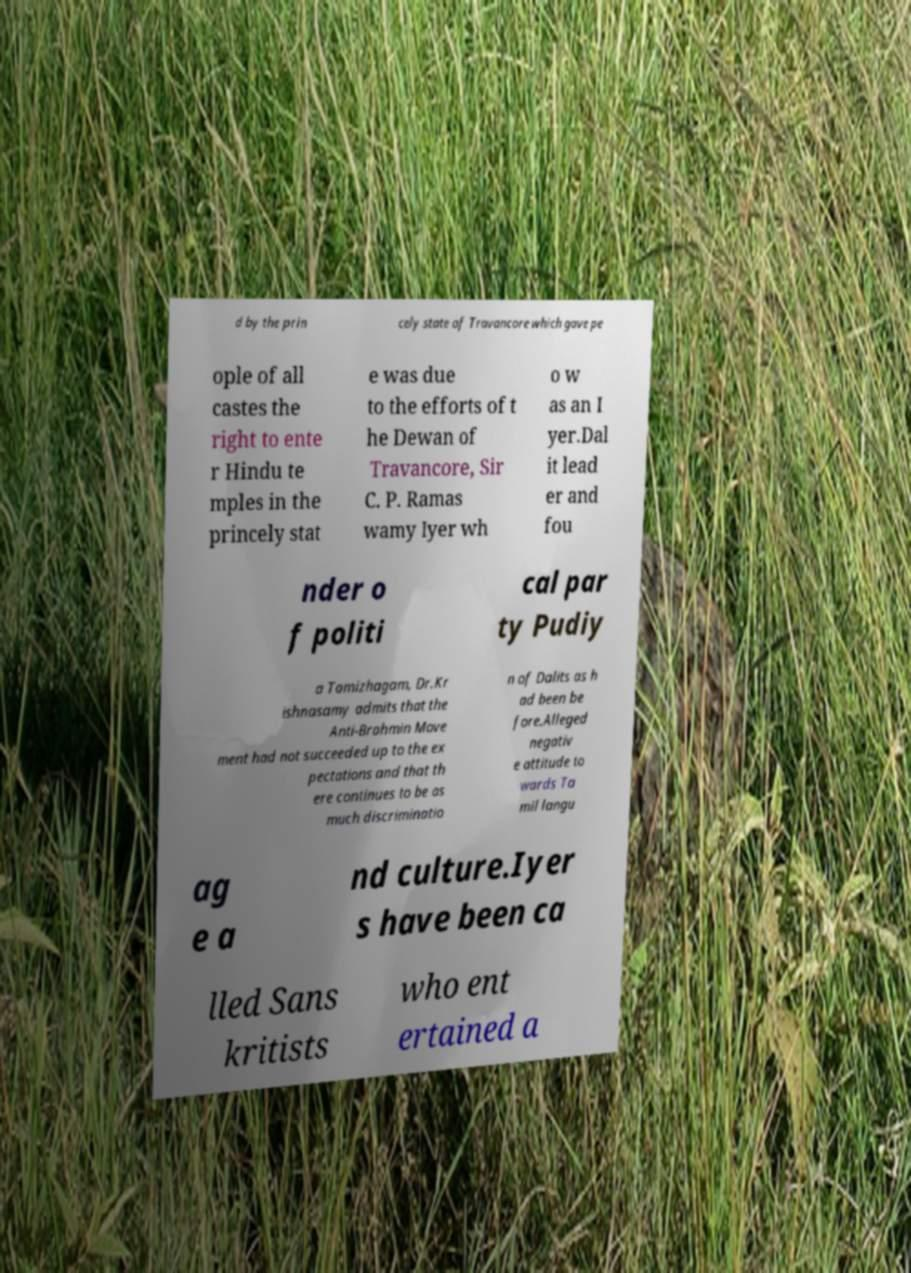Could you assist in decoding the text presented in this image and type it out clearly? d by the prin cely state of Travancore which gave pe ople of all castes the right to ente r Hindu te mples in the princely stat e was due to the efforts of t he Dewan of Travancore, Sir C. P. Ramas wamy Iyer wh o w as an I yer.Dal it lead er and fou nder o f politi cal par ty Pudiy a Tamizhagam, Dr.Kr ishnasamy admits that the Anti-Brahmin Move ment had not succeeded up to the ex pectations and that th ere continues to be as much discriminatio n of Dalits as h ad been be fore.Alleged negativ e attitude to wards Ta mil langu ag e a nd culture.Iyer s have been ca lled Sans kritists who ent ertained a 